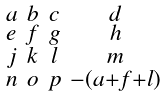<formula> <loc_0><loc_0><loc_500><loc_500>\begin{smallmatrix} a & b & c & d \\ e & f & g & h \\ j & k & l & m \\ n & o & p & - ( a + f + l ) \end{smallmatrix}</formula> 